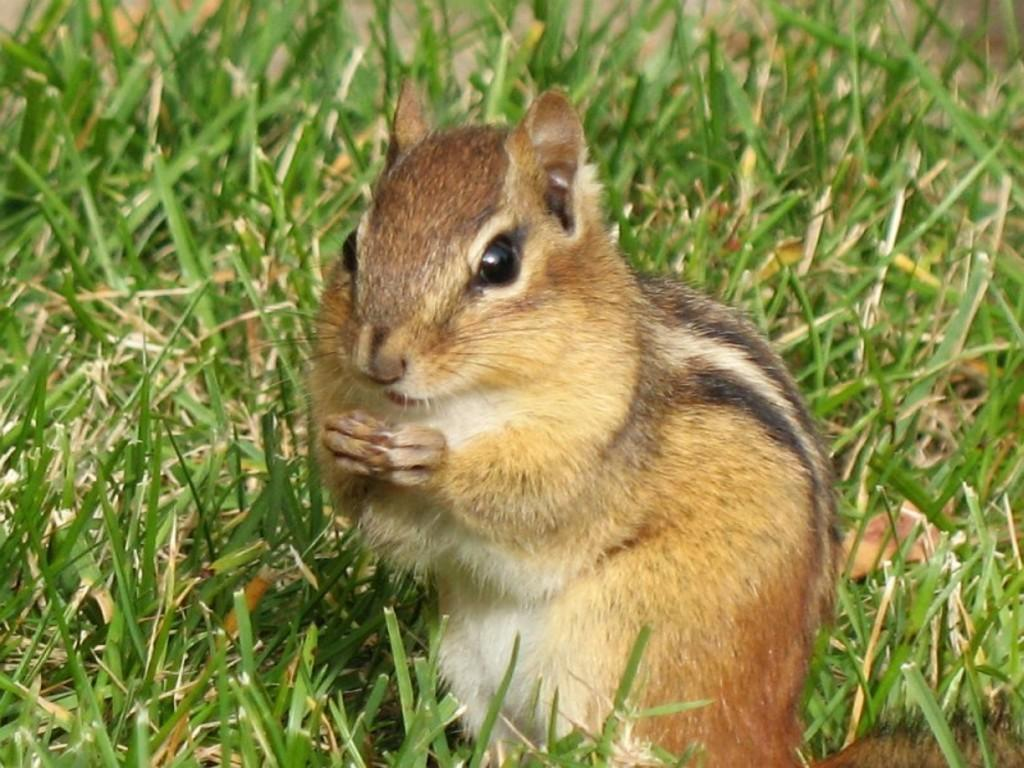What type of animal can be seen in the image? There is a squirrel in the image. What is the ground covered with in the image? There is grass on the ground in the image. What color is the pail that the squirrel is holding in the image? There is no pail present in the image; the squirrel is not holding anything. 